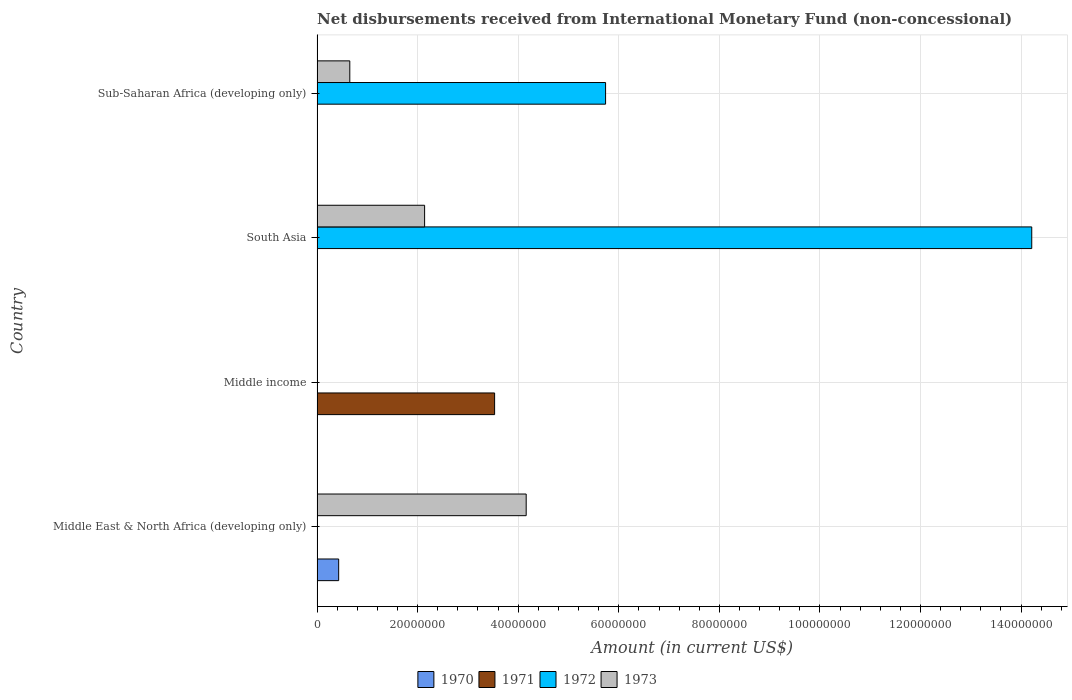How many different coloured bars are there?
Your answer should be very brief. 4. Are the number of bars on each tick of the Y-axis equal?
Your answer should be very brief. No. What is the label of the 2nd group of bars from the top?
Offer a very short reply. South Asia. What is the amount of disbursements received from International Monetary Fund in 1972 in Sub-Saharan Africa (developing only)?
Give a very brief answer. 5.74e+07. Across all countries, what is the maximum amount of disbursements received from International Monetary Fund in 1970?
Give a very brief answer. 4.30e+06. In which country was the amount of disbursements received from International Monetary Fund in 1971 maximum?
Offer a very short reply. Middle income. What is the total amount of disbursements received from International Monetary Fund in 1971 in the graph?
Give a very brief answer. 3.53e+07. What is the difference between the amount of disbursements received from International Monetary Fund in 1972 in South Asia and that in Sub-Saharan Africa (developing only)?
Your answer should be very brief. 8.48e+07. What is the average amount of disbursements received from International Monetary Fund in 1971 per country?
Keep it short and to the point. 8.83e+06. What is the difference between the amount of disbursements received from International Monetary Fund in 1972 and amount of disbursements received from International Monetary Fund in 1973 in Sub-Saharan Africa (developing only)?
Offer a terse response. 5.09e+07. In how many countries, is the amount of disbursements received from International Monetary Fund in 1970 greater than 104000000 US$?
Ensure brevity in your answer.  0. What is the ratio of the amount of disbursements received from International Monetary Fund in 1972 in South Asia to that in Sub-Saharan Africa (developing only)?
Provide a succinct answer. 2.48. Is the difference between the amount of disbursements received from International Monetary Fund in 1972 in South Asia and Sub-Saharan Africa (developing only) greater than the difference between the amount of disbursements received from International Monetary Fund in 1973 in South Asia and Sub-Saharan Africa (developing only)?
Offer a terse response. Yes. What is the difference between the highest and the second highest amount of disbursements received from International Monetary Fund in 1973?
Keep it short and to the point. 2.02e+07. What is the difference between the highest and the lowest amount of disbursements received from International Monetary Fund in 1970?
Give a very brief answer. 4.30e+06. Is it the case that in every country, the sum of the amount of disbursements received from International Monetary Fund in 1970 and amount of disbursements received from International Monetary Fund in 1972 is greater than the sum of amount of disbursements received from International Monetary Fund in 1973 and amount of disbursements received from International Monetary Fund in 1971?
Keep it short and to the point. No. How many countries are there in the graph?
Make the answer very short. 4. Does the graph contain grids?
Provide a succinct answer. Yes. How are the legend labels stacked?
Give a very brief answer. Horizontal. What is the title of the graph?
Ensure brevity in your answer.  Net disbursements received from International Monetary Fund (non-concessional). What is the label or title of the X-axis?
Make the answer very short. Amount (in current US$). What is the Amount (in current US$) of 1970 in Middle East & North Africa (developing only)?
Offer a terse response. 4.30e+06. What is the Amount (in current US$) in 1972 in Middle East & North Africa (developing only)?
Keep it short and to the point. 0. What is the Amount (in current US$) in 1973 in Middle East & North Africa (developing only)?
Offer a terse response. 4.16e+07. What is the Amount (in current US$) in 1971 in Middle income?
Your response must be concise. 3.53e+07. What is the Amount (in current US$) of 1972 in Middle income?
Your answer should be compact. 0. What is the Amount (in current US$) in 1971 in South Asia?
Ensure brevity in your answer.  0. What is the Amount (in current US$) of 1972 in South Asia?
Your answer should be compact. 1.42e+08. What is the Amount (in current US$) of 1973 in South Asia?
Your answer should be compact. 2.14e+07. What is the Amount (in current US$) of 1970 in Sub-Saharan Africa (developing only)?
Your response must be concise. 0. What is the Amount (in current US$) of 1971 in Sub-Saharan Africa (developing only)?
Offer a terse response. 0. What is the Amount (in current US$) in 1972 in Sub-Saharan Africa (developing only)?
Ensure brevity in your answer.  5.74e+07. What is the Amount (in current US$) of 1973 in Sub-Saharan Africa (developing only)?
Offer a terse response. 6.51e+06. Across all countries, what is the maximum Amount (in current US$) of 1970?
Your response must be concise. 4.30e+06. Across all countries, what is the maximum Amount (in current US$) in 1971?
Keep it short and to the point. 3.53e+07. Across all countries, what is the maximum Amount (in current US$) in 1972?
Your answer should be compact. 1.42e+08. Across all countries, what is the maximum Amount (in current US$) in 1973?
Make the answer very short. 4.16e+07. Across all countries, what is the minimum Amount (in current US$) in 1971?
Ensure brevity in your answer.  0. Across all countries, what is the minimum Amount (in current US$) of 1972?
Offer a very short reply. 0. Across all countries, what is the minimum Amount (in current US$) of 1973?
Make the answer very short. 0. What is the total Amount (in current US$) of 1970 in the graph?
Provide a succinct answer. 4.30e+06. What is the total Amount (in current US$) in 1971 in the graph?
Make the answer very short. 3.53e+07. What is the total Amount (in current US$) of 1972 in the graph?
Provide a succinct answer. 2.00e+08. What is the total Amount (in current US$) of 1973 in the graph?
Your answer should be compact. 6.95e+07. What is the difference between the Amount (in current US$) in 1973 in Middle East & North Africa (developing only) and that in South Asia?
Keep it short and to the point. 2.02e+07. What is the difference between the Amount (in current US$) of 1973 in Middle East & North Africa (developing only) and that in Sub-Saharan Africa (developing only)?
Ensure brevity in your answer.  3.51e+07. What is the difference between the Amount (in current US$) in 1972 in South Asia and that in Sub-Saharan Africa (developing only)?
Provide a succinct answer. 8.48e+07. What is the difference between the Amount (in current US$) in 1973 in South Asia and that in Sub-Saharan Africa (developing only)?
Provide a short and direct response. 1.49e+07. What is the difference between the Amount (in current US$) of 1970 in Middle East & North Africa (developing only) and the Amount (in current US$) of 1971 in Middle income?
Offer a terse response. -3.10e+07. What is the difference between the Amount (in current US$) of 1970 in Middle East & North Africa (developing only) and the Amount (in current US$) of 1972 in South Asia?
Offer a very short reply. -1.38e+08. What is the difference between the Amount (in current US$) in 1970 in Middle East & North Africa (developing only) and the Amount (in current US$) in 1973 in South Asia?
Offer a terse response. -1.71e+07. What is the difference between the Amount (in current US$) in 1970 in Middle East & North Africa (developing only) and the Amount (in current US$) in 1972 in Sub-Saharan Africa (developing only)?
Make the answer very short. -5.31e+07. What is the difference between the Amount (in current US$) in 1970 in Middle East & North Africa (developing only) and the Amount (in current US$) in 1973 in Sub-Saharan Africa (developing only)?
Keep it short and to the point. -2.21e+06. What is the difference between the Amount (in current US$) of 1971 in Middle income and the Amount (in current US$) of 1972 in South Asia?
Your response must be concise. -1.07e+08. What is the difference between the Amount (in current US$) of 1971 in Middle income and the Amount (in current US$) of 1973 in South Asia?
Give a very brief answer. 1.39e+07. What is the difference between the Amount (in current US$) of 1971 in Middle income and the Amount (in current US$) of 1972 in Sub-Saharan Africa (developing only)?
Keep it short and to the point. -2.21e+07. What is the difference between the Amount (in current US$) of 1971 in Middle income and the Amount (in current US$) of 1973 in Sub-Saharan Africa (developing only)?
Your response must be concise. 2.88e+07. What is the difference between the Amount (in current US$) of 1972 in South Asia and the Amount (in current US$) of 1973 in Sub-Saharan Africa (developing only)?
Ensure brevity in your answer.  1.36e+08. What is the average Amount (in current US$) of 1970 per country?
Ensure brevity in your answer.  1.08e+06. What is the average Amount (in current US$) of 1971 per country?
Offer a terse response. 8.83e+06. What is the average Amount (in current US$) in 1972 per country?
Give a very brief answer. 4.99e+07. What is the average Amount (in current US$) in 1973 per country?
Give a very brief answer. 1.74e+07. What is the difference between the Amount (in current US$) in 1970 and Amount (in current US$) in 1973 in Middle East & North Africa (developing only)?
Keep it short and to the point. -3.73e+07. What is the difference between the Amount (in current US$) of 1972 and Amount (in current US$) of 1973 in South Asia?
Keep it short and to the point. 1.21e+08. What is the difference between the Amount (in current US$) in 1972 and Amount (in current US$) in 1973 in Sub-Saharan Africa (developing only)?
Offer a terse response. 5.09e+07. What is the ratio of the Amount (in current US$) of 1973 in Middle East & North Africa (developing only) to that in South Asia?
Provide a succinct answer. 1.94. What is the ratio of the Amount (in current US$) in 1973 in Middle East & North Africa (developing only) to that in Sub-Saharan Africa (developing only)?
Your answer should be compact. 6.39. What is the ratio of the Amount (in current US$) of 1972 in South Asia to that in Sub-Saharan Africa (developing only)?
Your response must be concise. 2.48. What is the ratio of the Amount (in current US$) in 1973 in South Asia to that in Sub-Saharan Africa (developing only)?
Your answer should be compact. 3.29. What is the difference between the highest and the second highest Amount (in current US$) in 1973?
Provide a succinct answer. 2.02e+07. What is the difference between the highest and the lowest Amount (in current US$) in 1970?
Keep it short and to the point. 4.30e+06. What is the difference between the highest and the lowest Amount (in current US$) in 1971?
Provide a short and direct response. 3.53e+07. What is the difference between the highest and the lowest Amount (in current US$) in 1972?
Your response must be concise. 1.42e+08. What is the difference between the highest and the lowest Amount (in current US$) in 1973?
Make the answer very short. 4.16e+07. 